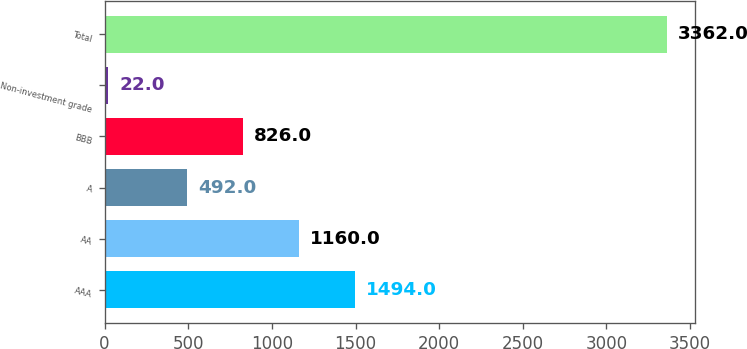<chart> <loc_0><loc_0><loc_500><loc_500><bar_chart><fcel>AAA<fcel>AA<fcel>A<fcel>BBB<fcel>Non-investment grade<fcel>Total<nl><fcel>1494<fcel>1160<fcel>492<fcel>826<fcel>22<fcel>3362<nl></chart> 